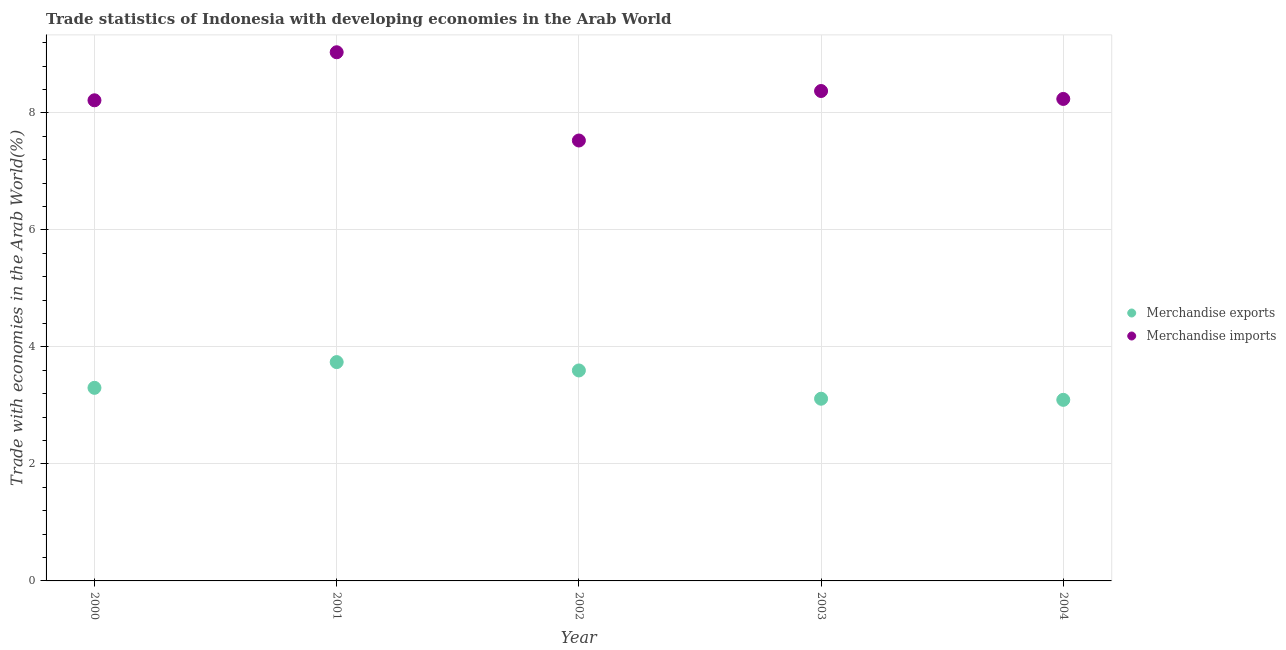How many different coloured dotlines are there?
Your answer should be very brief. 2. Is the number of dotlines equal to the number of legend labels?
Your response must be concise. Yes. What is the merchandise imports in 2000?
Offer a very short reply. 8.22. Across all years, what is the maximum merchandise imports?
Ensure brevity in your answer.  9.04. Across all years, what is the minimum merchandise imports?
Make the answer very short. 7.53. In which year was the merchandise imports maximum?
Provide a succinct answer. 2001. In which year was the merchandise exports minimum?
Offer a very short reply. 2004. What is the total merchandise imports in the graph?
Your response must be concise. 41.4. What is the difference between the merchandise imports in 2001 and that in 2002?
Offer a terse response. 1.51. What is the difference between the merchandise exports in 2003 and the merchandise imports in 2004?
Your answer should be compact. -5.13. What is the average merchandise imports per year?
Give a very brief answer. 8.28. In the year 2002, what is the difference between the merchandise imports and merchandise exports?
Your answer should be compact. 3.93. In how many years, is the merchandise exports greater than 3.6 %?
Provide a short and direct response. 1. What is the ratio of the merchandise exports in 2001 to that in 2003?
Your response must be concise. 1.2. What is the difference between the highest and the second highest merchandise imports?
Offer a very short reply. 0.66. What is the difference between the highest and the lowest merchandise exports?
Provide a succinct answer. 0.65. In how many years, is the merchandise exports greater than the average merchandise exports taken over all years?
Your response must be concise. 2. Is the sum of the merchandise exports in 2003 and 2004 greater than the maximum merchandise imports across all years?
Provide a short and direct response. No. How many dotlines are there?
Give a very brief answer. 2. How many years are there in the graph?
Ensure brevity in your answer.  5. Does the graph contain any zero values?
Your answer should be very brief. No. How many legend labels are there?
Give a very brief answer. 2. What is the title of the graph?
Your response must be concise. Trade statistics of Indonesia with developing economies in the Arab World. What is the label or title of the Y-axis?
Give a very brief answer. Trade with economies in the Arab World(%). What is the Trade with economies in the Arab World(%) of Merchandise exports in 2000?
Your answer should be compact. 3.3. What is the Trade with economies in the Arab World(%) of Merchandise imports in 2000?
Your answer should be very brief. 8.22. What is the Trade with economies in the Arab World(%) of Merchandise exports in 2001?
Offer a very short reply. 3.74. What is the Trade with economies in the Arab World(%) in Merchandise imports in 2001?
Your answer should be very brief. 9.04. What is the Trade with economies in the Arab World(%) in Merchandise exports in 2002?
Your answer should be compact. 3.6. What is the Trade with economies in the Arab World(%) in Merchandise imports in 2002?
Your response must be concise. 7.53. What is the Trade with economies in the Arab World(%) of Merchandise exports in 2003?
Provide a short and direct response. 3.11. What is the Trade with economies in the Arab World(%) in Merchandise imports in 2003?
Keep it short and to the point. 8.38. What is the Trade with economies in the Arab World(%) in Merchandise exports in 2004?
Ensure brevity in your answer.  3.1. What is the Trade with economies in the Arab World(%) of Merchandise imports in 2004?
Your answer should be compact. 8.24. Across all years, what is the maximum Trade with economies in the Arab World(%) in Merchandise exports?
Offer a very short reply. 3.74. Across all years, what is the maximum Trade with economies in the Arab World(%) in Merchandise imports?
Give a very brief answer. 9.04. Across all years, what is the minimum Trade with economies in the Arab World(%) of Merchandise exports?
Ensure brevity in your answer.  3.1. Across all years, what is the minimum Trade with economies in the Arab World(%) in Merchandise imports?
Offer a terse response. 7.53. What is the total Trade with economies in the Arab World(%) of Merchandise exports in the graph?
Your answer should be compact. 16.85. What is the total Trade with economies in the Arab World(%) in Merchandise imports in the graph?
Keep it short and to the point. 41.4. What is the difference between the Trade with economies in the Arab World(%) of Merchandise exports in 2000 and that in 2001?
Keep it short and to the point. -0.44. What is the difference between the Trade with economies in the Arab World(%) of Merchandise imports in 2000 and that in 2001?
Your answer should be compact. -0.82. What is the difference between the Trade with economies in the Arab World(%) in Merchandise exports in 2000 and that in 2002?
Ensure brevity in your answer.  -0.3. What is the difference between the Trade with economies in the Arab World(%) of Merchandise imports in 2000 and that in 2002?
Give a very brief answer. 0.69. What is the difference between the Trade with economies in the Arab World(%) of Merchandise exports in 2000 and that in 2003?
Give a very brief answer. 0.19. What is the difference between the Trade with economies in the Arab World(%) in Merchandise imports in 2000 and that in 2003?
Your answer should be very brief. -0.16. What is the difference between the Trade with economies in the Arab World(%) of Merchandise exports in 2000 and that in 2004?
Keep it short and to the point. 0.21. What is the difference between the Trade with economies in the Arab World(%) in Merchandise imports in 2000 and that in 2004?
Your answer should be very brief. -0.02. What is the difference between the Trade with economies in the Arab World(%) in Merchandise exports in 2001 and that in 2002?
Your answer should be compact. 0.14. What is the difference between the Trade with economies in the Arab World(%) in Merchandise imports in 2001 and that in 2002?
Provide a succinct answer. 1.51. What is the difference between the Trade with economies in the Arab World(%) in Merchandise exports in 2001 and that in 2003?
Your answer should be very brief. 0.63. What is the difference between the Trade with economies in the Arab World(%) of Merchandise imports in 2001 and that in 2003?
Ensure brevity in your answer.  0.66. What is the difference between the Trade with economies in the Arab World(%) of Merchandise exports in 2001 and that in 2004?
Your response must be concise. 0.65. What is the difference between the Trade with economies in the Arab World(%) of Merchandise imports in 2001 and that in 2004?
Your answer should be compact. 0.8. What is the difference between the Trade with economies in the Arab World(%) of Merchandise exports in 2002 and that in 2003?
Your response must be concise. 0.48. What is the difference between the Trade with economies in the Arab World(%) in Merchandise imports in 2002 and that in 2003?
Ensure brevity in your answer.  -0.85. What is the difference between the Trade with economies in the Arab World(%) of Merchandise exports in 2002 and that in 2004?
Provide a short and direct response. 0.5. What is the difference between the Trade with economies in the Arab World(%) of Merchandise imports in 2002 and that in 2004?
Your answer should be very brief. -0.71. What is the difference between the Trade with economies in the Arab World(%) of Merchandise exports in 2003 and that in 2004?
Provide a short and direct response. 0.02. What is the difference between the Trade with economies in the Arab World(%) in Merchandise imports in 2003 and that in 2004?
Your answer should be very brief. 0.14. What is the difference between the Trade with economies in the Arab World(%) in Merchandise exports in 2000 and the Trade with economies in the Arab World(%) in Merchandise imports in 2001?
Your answer should be very brief. -5.74. What is the difference between the Trade with economies in the Arab World(%) of Merchandise exports in 2000 and the Trade with economies in the Arab World(%) of Merchandise imports in 2002?
Your answer should be very brief. -4.23. What is the difference between the Trade with economies in the Arab World(%) of Merchandise exports in 2000 and the Trade with economies in the Arab World(%) of Merchandise imports in 2003?
Provide a succinct answer. -5.07. What is the difference between the Trade with economies in the Arab World(%) of Merchandise exports in 2000 and the Trade with economies in the Arab World(%) of Merchandise imports in 2004?
Offer a very short reply. -4.94. What is the difference between the Trade with economies in the Arab World(%) of Merchandise exports in 2001 and the Trade with economies in the Arab World(%) of Merchandise imports in 2002?
Offer a terse response. -3.79. What is the difference between the Trade with economies in the Arab World(%) of Merchandise exports in 2001 and the Trade with economies in the Arab World(%) of Merchandise imports in 2003?
Offer a terse response. -4.63. What is the difference between the Trade with economies in the Arab World(%) in Merchandise exports in 2001 and the Trade with economies in the Arab World(%) in Merchandise imports in 2004?
Give a very brief answer. -4.5. What is the difference between the Trade with economies in the Arab World(%) in Merchandise exports in 2002 and the Trade with economies in the Arab World(%) in Merchandise imports in 2003?
Offer a terse response. -4.78. What is the difference between the Trade with economies in the Arab World(%) of Merchandise exports in 2002 and the Trade with economies in the Arab World(%) of Merchandise imports in 2004?
Provide a short and direct response. -4.64. What is the difference between the Trade with economies in the Arab World(%) in Merchandise exports in 2003 and the Trade with economies in the Arab World(%) in Merchandise imports in 2004?
Offer a very short reply. -5.13. What is the average Trade with economies in the Arab World(%) of Merchandise exports per year?
Provide a succinct answer. 3.37. What is the average Trade with economies in the Arab World(%) in Merchandise imports per year?
Give a very brief answer. 8.28. In the year 2000, what is the difference between the Trade with economies in the Arab World(%) in Merchandise exports and Trade with economies in the Arab World(%) in Merchandise imports?
Provide a succinct answer. -4.92. In the year 2001, what is the difference between the Trade with economies in the Arab World(%) in Merchandise exports and Trade with economies in the Arab World(%) in Merchandise imports?
Your response must be concise. -5.3. In the year 2002, what is the difference between the Trade with economies in the Arab World(%) of Merchandise exports and Trade with economies in the Arab World(%) of Merchandise imports?
Your answer should be very brief. -3.93. In the year 2003, what is the difference between the Trade with economies in the Arab World(%) of Merchandise exports and Trade with economies in the Arab World(%) of Merchandise imports?
Offer a terse response. -5.26. In the year 2004, what is the difference between the Trade with economies in the Arab World(%) in Merchandise exports and Trade with economies in the Arab World(%) in Merchandise imports?
Offer a terse response. -5.14. What is the ratio of the Trade with economies in the Arab World(%) in Merchandise exports in 2000 to that in 2001?
Your answer should be compact. 0.88. What is the ratio of the Trade with economies in the Arab World(%) of Merchandise imports in 2000 to that in 2001?
Your response must be concise. 0.91. What is the ratio of the Trade with economies in the Arab World(%) in Merchandise exports in 2000 to that in 2002?
Your response must be concise. 0.92. What is the ratio of the Trade with economies in the Arab World(%) of Merchandise imports in 2000 to that in 2002?
Make the answer very short. 1.09. What is the ratio of the Trade with economies in the Arab World(%) in Merchandise exports in 2000 to that in 2003?
Offer a terse response. 1.06. What is the ratio of the Trade with economies in the Arab World(%) in Merchandise exports in 2000 to that in 2004?
Keep it short and to the point. 1.07. What is the ratio of the Trade with economies in the Arab World(%) of Merchandise exports in 2001 to that in 2002?
Provide a short and direct response. 1.04. What is the ratio of the Trade with economies in the Arab World(%) in Merchandise imports in 2001 to that in 2002?
Your answer should be very brief. 1.2. What is the ratio of the Trade with economies in the Arab World(%) in Merchandise exports in 2001 to that in 2003?
Give a very brief answer. 1.2. What is the ratio of the Trade with economies in the Arab World(%) in Merchandise imports in 2001 to that in 2003?
Your response must be concise. 1.08. What is the ratio of the Trade with economies in the Arab World(%) of Merchandise exports in 2001 to that in 2004?
Your answer should be very brief. 1.21. What is the ratio of the Trade with economies in the Arab World(%) in Merchandise imports in 2001 to that in 2004?
Make the answer very short. 1.1. What is the ratio of the Trade with economies in the Arab World(%) in Merchandise exports in 2002 to that in 2003?
Provide a short and direct response. 1.16. What is the ratio of the Trade with economies in the Arab World(%) of Merchandise imports in 2002 to that in 2003?
Offer a very short reply. 0.9. What is the ratio of the Trade with economies in the Arab World(%) of Merchandise exports in 2002 to that in 2004?
Offer a very short reply. 1.16. What is the ratio of the Trade with economies in the Arab World(%) in Merchandise imports in 2002 to that in 2004?
Give a very brief answer. 0.91. What is the ratio of the Trade with economies in the Arab World(%) in Merchandise imports in 2003 to that in 2004?
Your response must be concise. 1.02. What is the difference between the highest and the second highest Trade with economies in the Arab World(%) in Merchandise exports?
Offer a very short reply. 0.14. What is the difference between the highest and the second highest Trade with economies in the Arab World(%) of Merchandise imports?
Your response must be concise. 0.66. What is the difference between the highest and the lowest Trade with economies in the Arab World(%) of Merchandise exports?
Make the answer very short. 0.65. What is the difference between the highest and the lowest Trade with economies in the Arab World(%) of Merchandise imports?
Give a very brief answer. 1.51. 